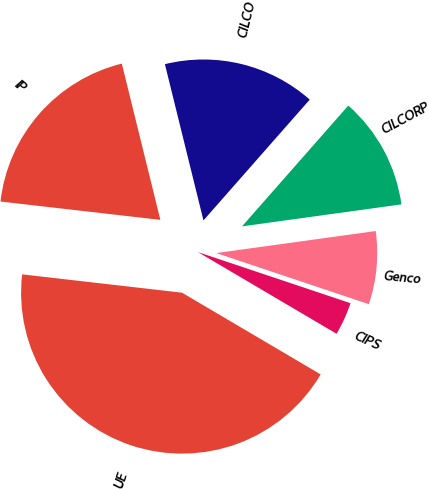Convert chart to OTSL. <chart><loc_0><loc_0><loc_500><loc_500><pie_chart><fcel>UE<fcel>CIPS<fcel>Genco<fcel>CILCORP<fcel>CILCO<fcel>IP<nl><fcel>43.33%<fcel>3.33%<fcel>7.33%<fcel>11.33%<fcel>15.33%<fcel>19.33%<nl></chart> 